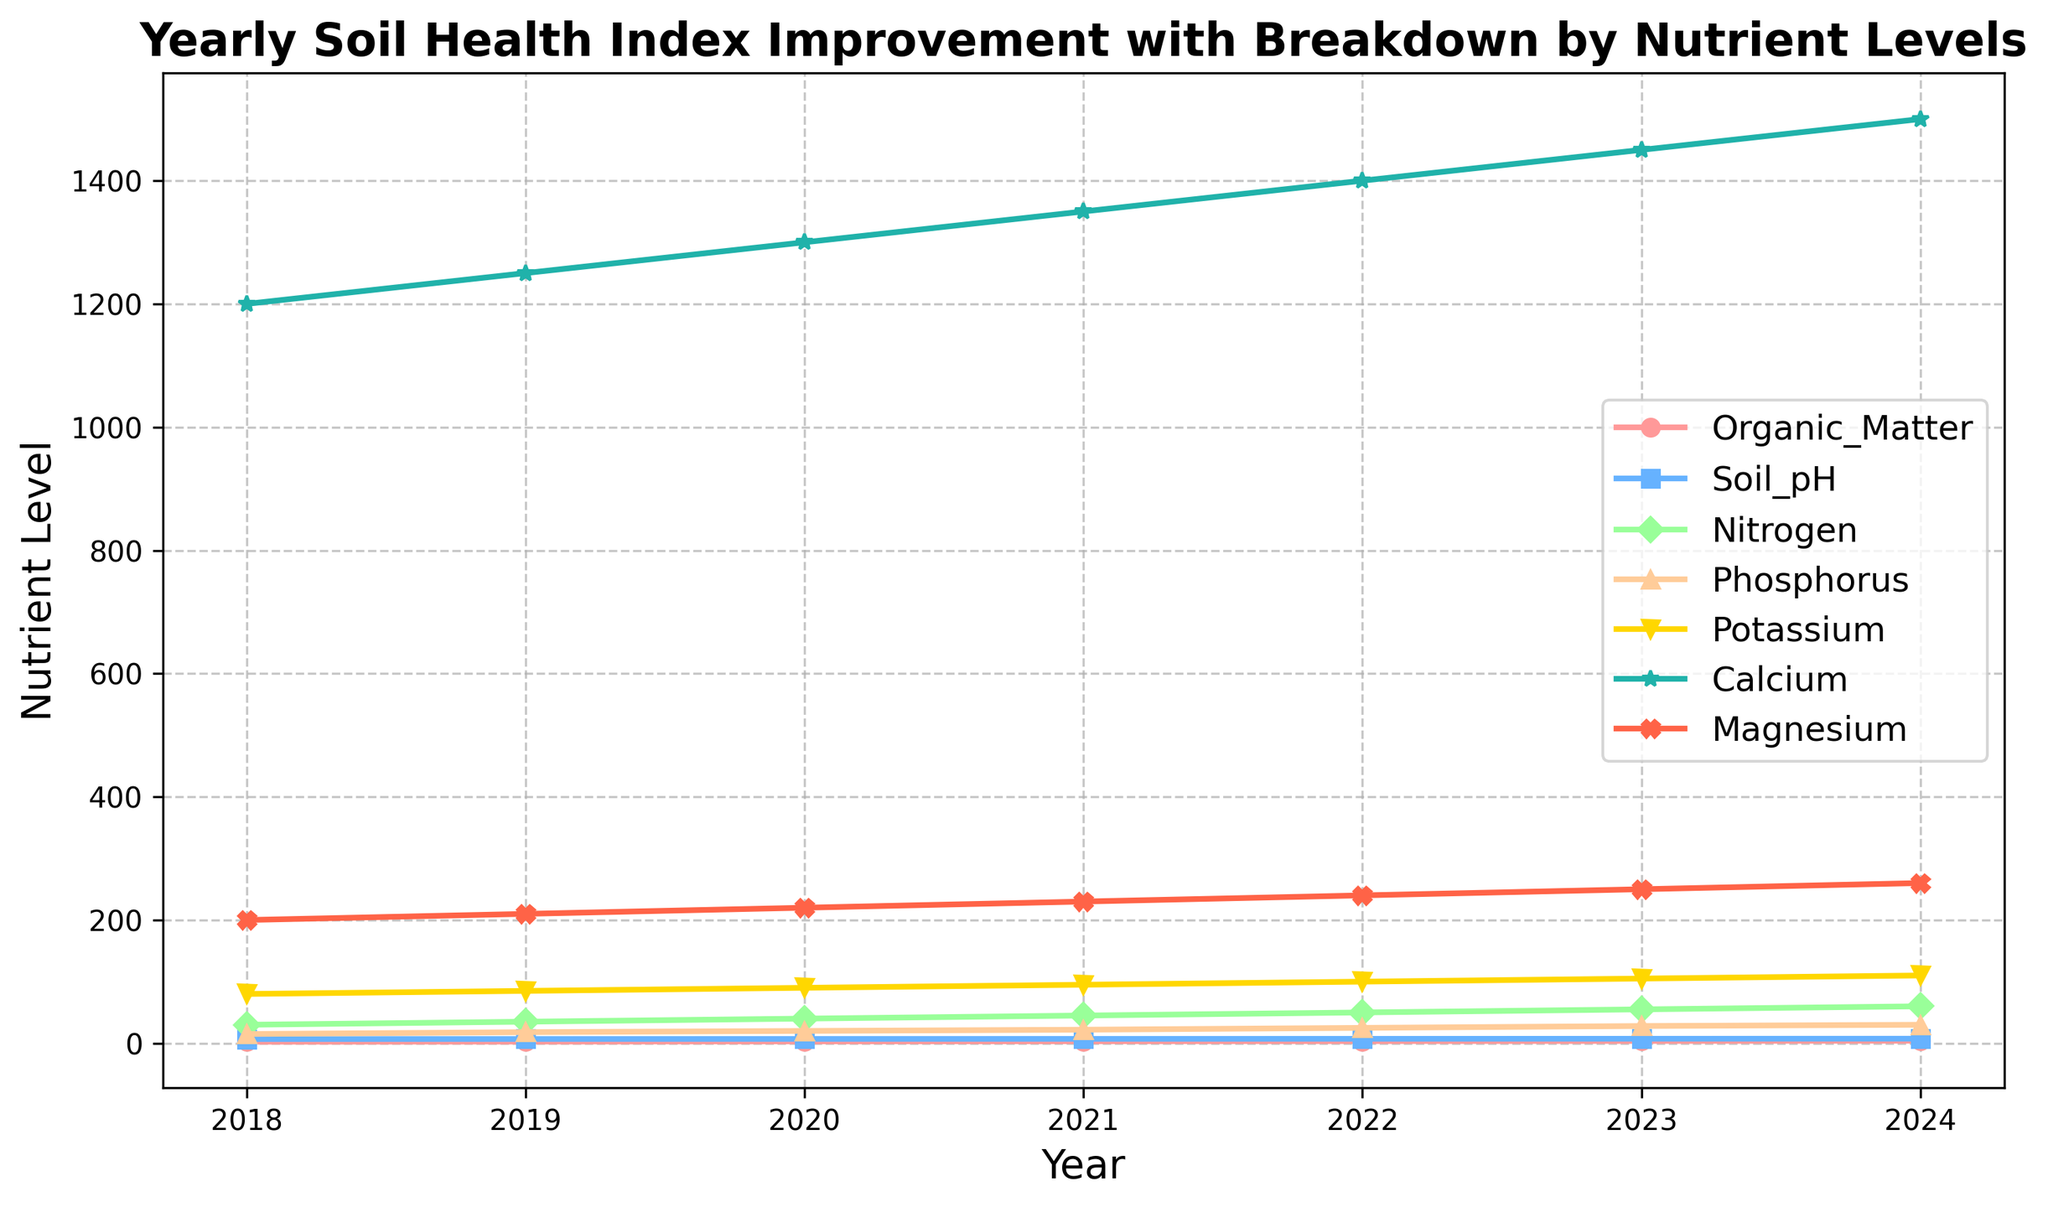What is the trend of the Organic Matter nutrient level from 2018 to 2024? The Organic Matter nutrient level consistently increases over the years. It starts from 2.5 in 2018 and rises to 4.0 in 2024.
Answer: Consistently increasing How does the Phosphorus level in 2023 compare to 2022? The Phosphorus level in 2023 is 3 units higher than that in 2022. It increases from 25 in 2022 to 28 in 2023.
Answer: Higher in 2023 Which year shows the highest Nitrogen level? To find the highest Nitrogen level, observe the trend line for Nitrogen across the years. The peak value is at 60 in 2024.
Answer: 2024 What are the colors used to represent the Organic Matter and Soil pH levels? Upon examining the plot, the Organic Matter is denoted in red and Soil pH in light blue.
Answer: Red for Organic Matter and light blue for Soil pH By how much has the Potassium level increased from 2018 to 2024? The Potassium level in 2018 is 80, and it increases to 110 in 2024. The difference is 110 - 80 = 30.
Answer: 30 What is the average Calcium level from 2021 to 2023? The Calcium levels across 2021, 2022, and 2023 are 1350, 1400, and 1450 respectively. Average = (1350 + 1400 + 1450) / 3 = 1400.
Answer: 1400 Which nutrient saw the smallest increase in its levels from 2018 to 2024? To identify the smallest increase, calculate the difference for each nutrient. The smallest increase is for Soil pH which increases from 6.8 to 7.4: 7.4 - 6.8 = 0.6.
Answer: Soil pH Compare the Magnesium levels in 2018 and 2024 and find the ratio. The Magnesium level is 200 in 2018 and 260 in 2024. The ratio is 260 / 200 = 1.3.
Answer: 1.3:1 What is the visible pattern for the Calcium level over the years? The Calcium level consistently rises year by year, starting from 1200 in 2018 to 1500 in 2024, showing a linear upward trend.
Answer: Linear upward trend Which nutrient has the steepest slope between any two consecutive years? By examining the lines' steepness, Nitrogen shows the steepest slope between the years 2018 and 2019, going from 30 to 35: slope = 35 - 30 = 5.
Answer: Nitrogen 